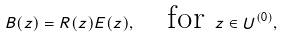<formula> <loc_0><loc_0><loc_500><loc_500>B ( z ) = R ( z ) E ( z ) , \quad \text {for } z \in U ^ { ( 0 ) } ,</formula> 